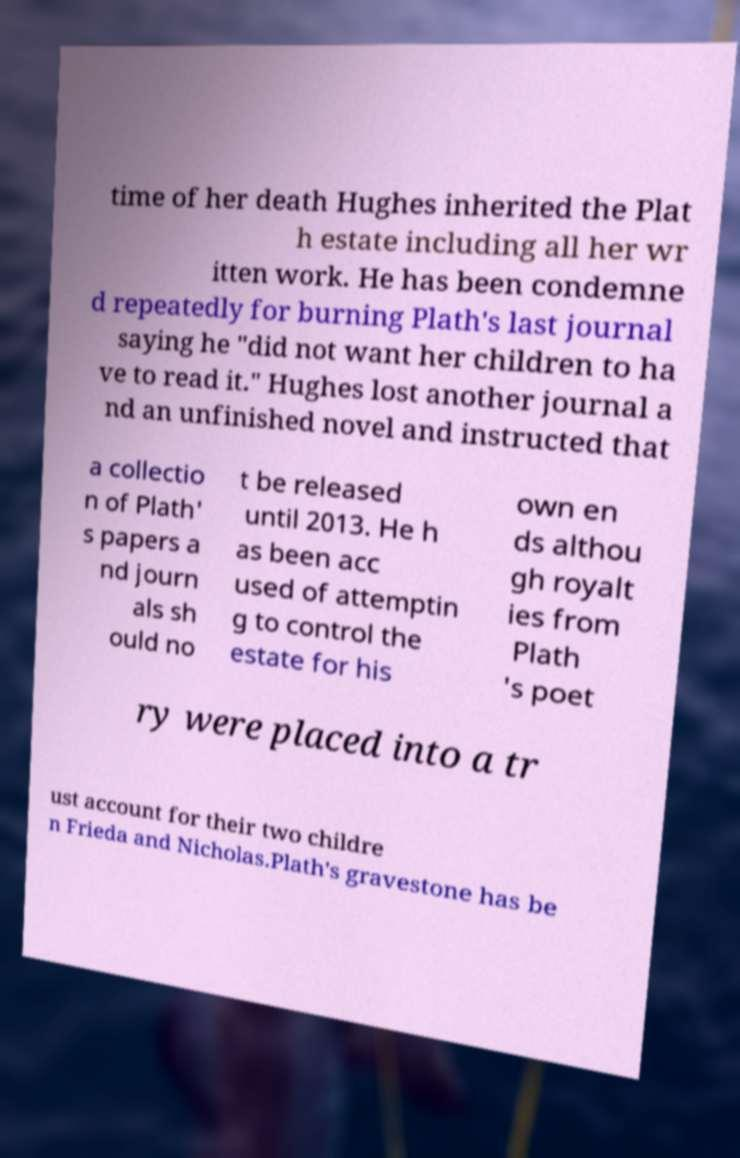Can you accurately transcribe the text from the provided image for me? time of her death Hughes inherited the Plat h estate including all her wr itten work. He has been condemne d repeatedly for burning Plath's last journal saying he "did not want her children to ha ve to read it." Hughes lost another journal a nd an unfinished novel and instructed that a collectio n of Plath' s papers a nd journ als sh ould no t be released until 2013. He h as been acc used of attemptin g to control the estate for his own en ds althou gh royalt ies from Plath 's poet ry were placed into a tr ust account for their two childre n Frieda and Nicholas.Plath's gravestone has be 